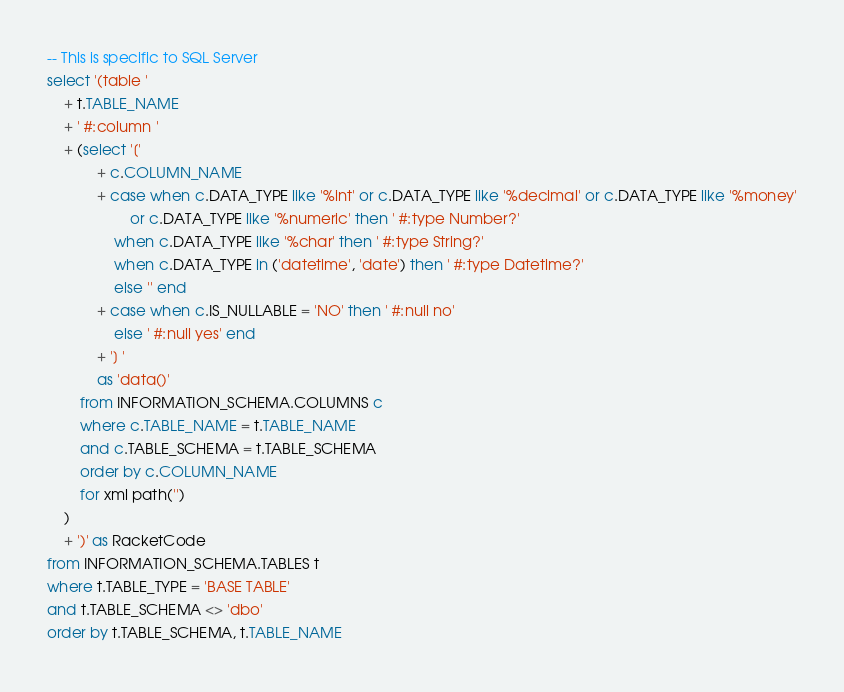Convert code to text. <code><loc_0><loc_0><loc_500><loc_500><_SQL_>-- This is specific to SQL Server
select '(table '
	+ t.TABLE_NAME
	+ ' #:column '
	+ (select '['
			+ c.COLUMN_NAME
			+ case when c.DATA_TYPE like '%int' or c.DATA_TYPE like '%decimal' or c.DATA_TYPE like '%money'
					or c.DATA_TYPE like '%numeric' then ' #:type Number?'
				when c.DATA_TYPE like '%char' then ' #:type String?'
				when c.DATA_TYPE in ('datetime', 'date') then ' #:type Datetime?'
				else '' end
			+ case when c.IS_NULLABLE = 'NO' then ' #:null no'
				else ' #:null yes' end
			+ '] '
			as 'data()'
		from INFORMATION_SCHEMA.COLUMNS c
		where c.TABLE_NAME = t.TABLE_NAME
		and c.TABLE_SCHEMA = t.TABLE_SCHEMA
		order by c.COLUMN_NAME
		for xml path('')
	)
	+ ')' as RacketCode
from INFORMATION_SCHEMA.TABLES t
where t.TABLE_TYPE = 'BASE TABLE'
and t.TABLE_SCHEMA <> 'dbo'
order by t.TABLE_SCHEMA, t.TABLE_NAME</code> 